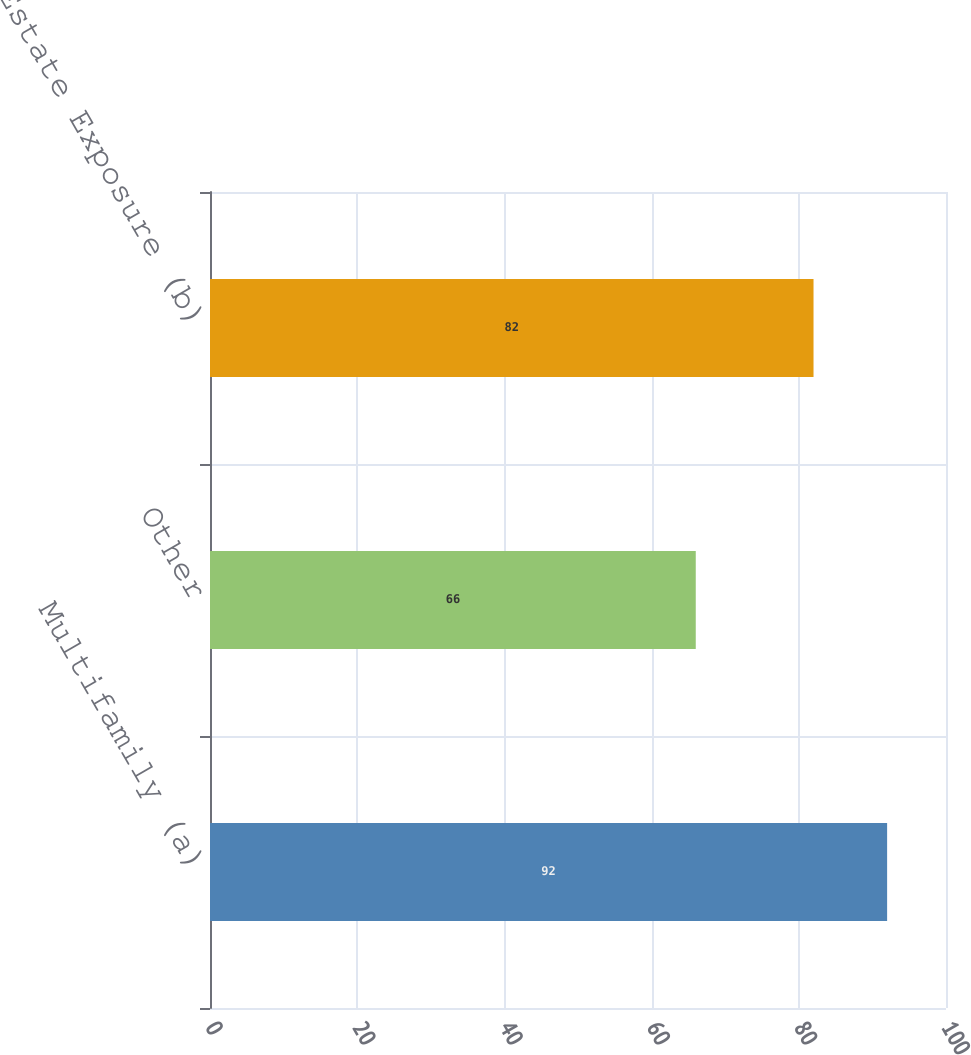Convert chart. <chart><loc_0><loc_0><loc_500><loc_500><bar_chart><fcel>Multifamily (a)<fcel>Other<fcel>Total Real Estate Exposure (b)<nl><fcel>92<fcel>66<fcel>82<nl></chart> 